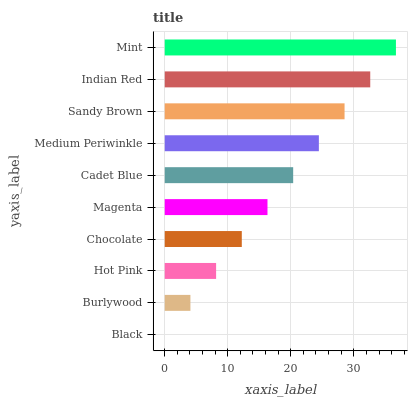Is Black the minimum?
Answer yes or no. Yes. Is Mint the maximum?
Answer yes or no. Yes. Is Burlywood the minimum?
Answer yes or no. No. Is Burlywood the maximum?
Answer yes or no. No. Is Burlywood greater than Black?
Answer yes or no. Yes. Is Black less than Burlywood?
Answer yes or no. Yes. Is Black greater than Burlywood?
Answer yes or no. No. Is Burlywood less than Black?
Answer yes or no. No. Is Cadet Blue the high median?
Answer yes or no. Yes. Is Magenta the low median?
Answer yes or no. Yes. Is Medium Periwinkle the high median?
Answer yes or no. No. Is Black the low median?
Answer yes or no. No. 